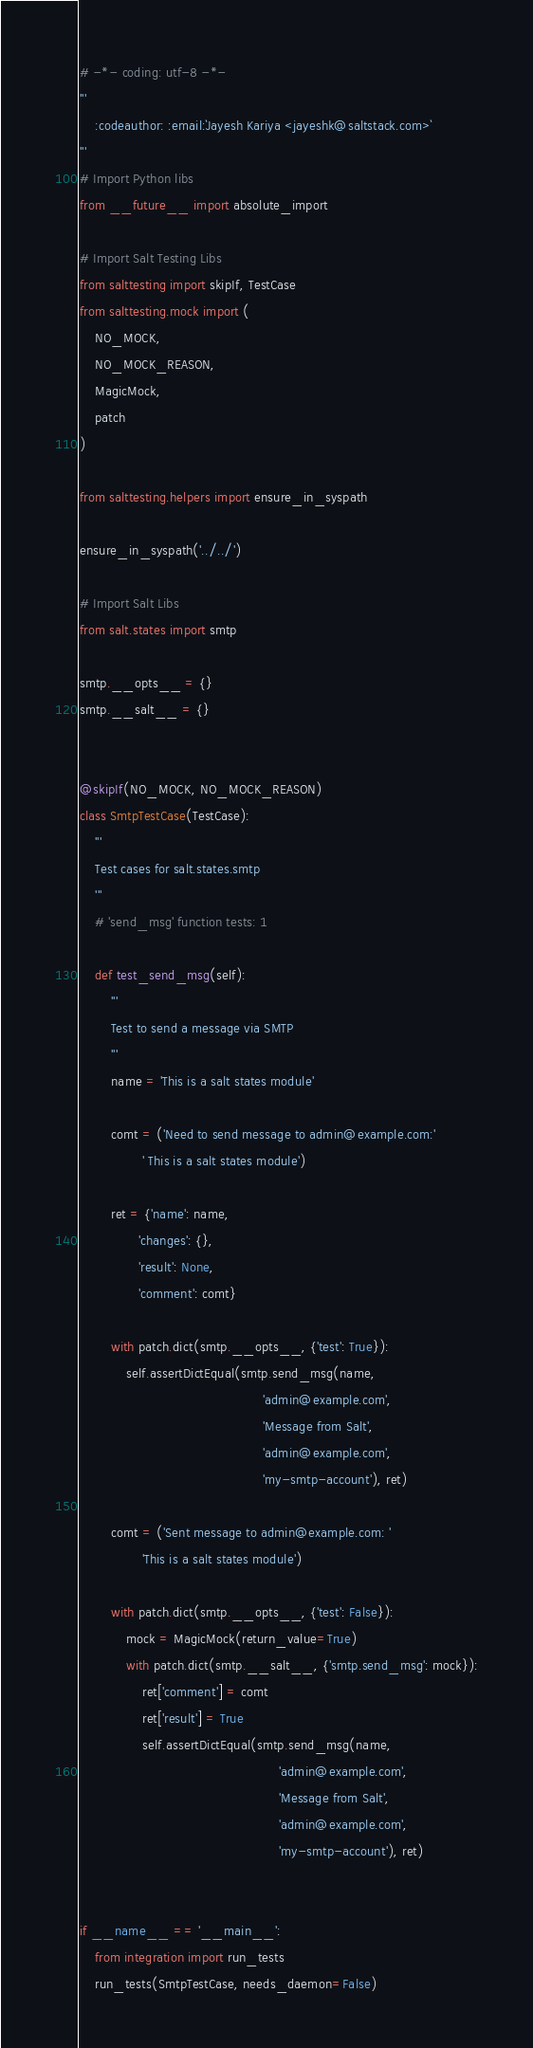<code> <loc_0><loc_0><loc_500><loc_500><_Python_># -*- coding: utf-8 -*-
'''
    :codeauthor: :email:`Jayesh Kariya <jayeshk@saltstack.com>`
'''
# Import Python libs
from __future__ import absolute_import

# Import Salt Testing Libs
from salttesting import skipIf, TestCase
from salttesting.mock import (
    NO_MOCK,
    NO_MOCK_REASON,
    MagicMock,
    patch
)

from salttesting.helpers import ensure_in_syspath

ensure_in_syspath('../../')

# Import Salt Libs
from salt.states import smtp

smtp.__opts__ = {}
smtp.__salt__ = {}


@skipIf(NO_MOCK, NO_MOCK_REASON)
class SmtpTestCase(TestCase):
    '''
    Test cases for salt.states.smtp
    '''
    # 'send_msg' function tests: 1

    def test_send_msg(self):
        '''
        Test to send a message via SMTP
        '''
        name = 'This is a salt states module'

        comt = ('Need to send message to admin@example.com:'
                ' This is a salt states module')

        ret = {'name': name,
               'changes': {},
               'result': None,
               'comment': comt}

        with patch.dict(smtp.__opts__, {'test': True}):
            self.assertDictEqual(smtp.send_msg(name,
                                               'admin@example.com',
                                               'Message from Salt',
                                               'admin@example.com',
                                               'my-smtp-account'), ret)

        comt = ('Sent message to admin@example.com: '
                'This is a salt states module')

        with patch.dict(smtp.__opts__, {'test': False}):
            mock = MagicMock(return_value=True)
            with patch.dict(smtp.__salt__, {'smtp.send_msg': mock}):
                ret['comment'] = comt
                ret['result'] = True
                self.assertDictEqual(smtp.send_msg(name,
                                                   'admin@example.com',
                                                   'Message from Salt',
                                                   'admin@example.com',
                                                   'my-smtp-account'), ret)


if __name__ == '__main__':
    from integration import run_tests
    run_tests(SmtpTestCase, needs_daemon=False)
</code> 